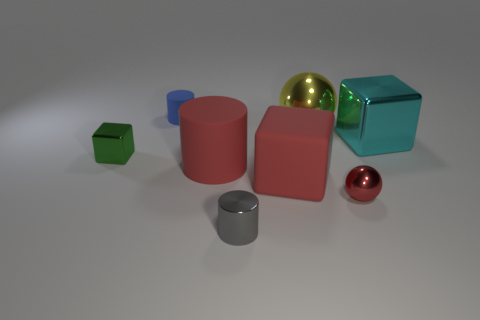How many tiny objects are cyan blocks or red matte cylinders?
Make the answer very short. 0. What is the size of the shiny ball that is the same color as the big matte cylinder?
Make the answer very short. Small. Is there a yellow thing that has the same material as the cyan thing?
Keep it short and to the point. Yes. What material is the small thing that is behind the big shiny cube?
Ensure brevity in your answer.  Rubber. There is a shiny sphere that is in front of the red block; is its color the same as the large thing that is on the left side of the big red rubber block?
Provide a succinct answer. Yes. What color is the matte thing that is the same size as the red metal thing?
Provide a succinct answer. Blue. How many other things are the same shape as the blue matte thing?
Offer a very short reply. 2. There is a ball in front of the cyan block; what is its size?
Give a very brief answer. Small. There is a matte thing on the left side of the red cylinder; what number of green metallic cubes are on the right side of it?
Give a very brief answer. 0. What number of other objects are the same size as the gray metal cylinder?
Your answer should be compact. 3. 